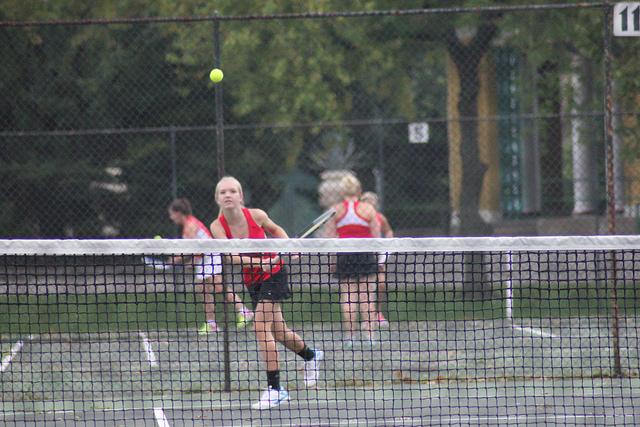How tall is the tennis net?
Be succinct. 3 feet. What are they hitting the ball over?
Be succinct. Net. What are the white lines made out of?
Be succinct. Paint. Are these professional players?
Quick response, please. No. What color are the woman wearing?
Concise answer only. Red. What color are the woman's socks?
Quick response, please. Black. 